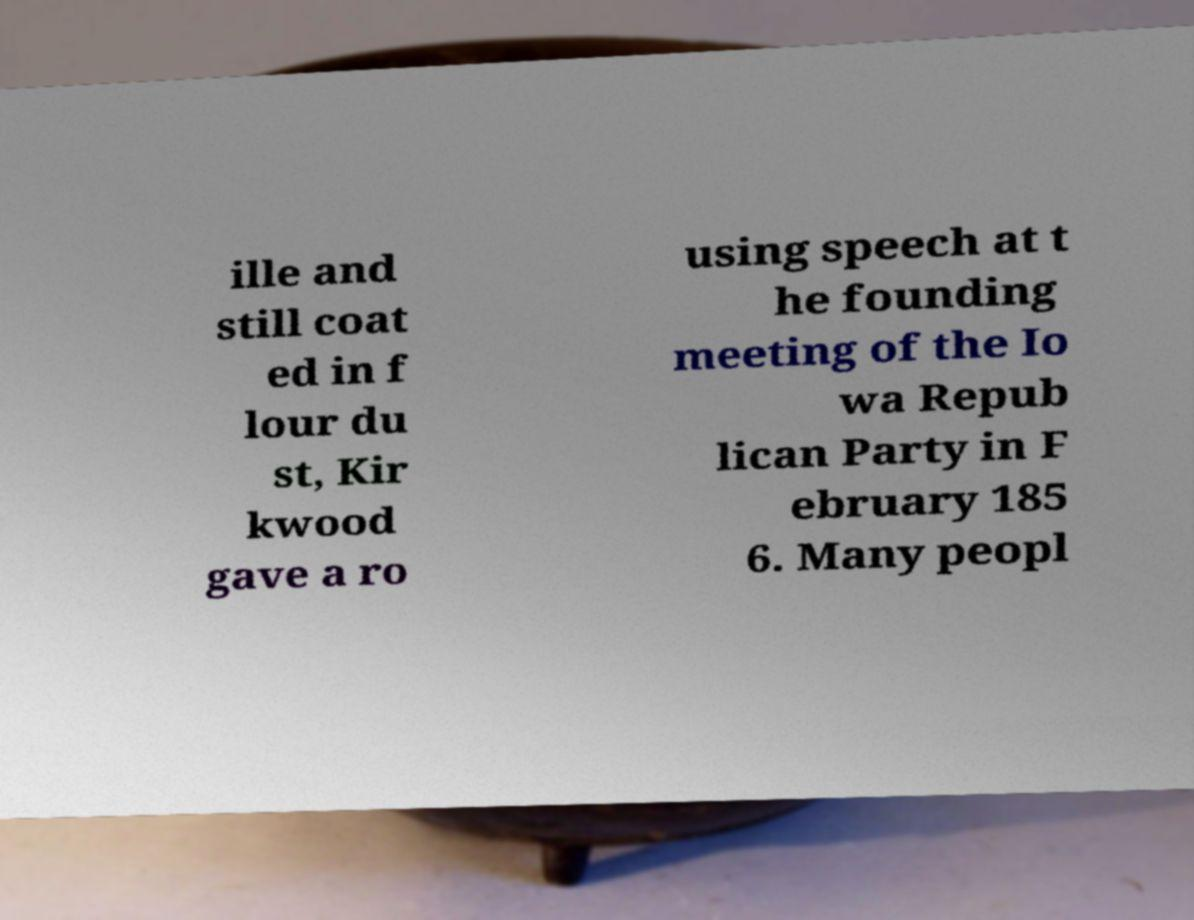Could you extract and type out the text from this image? ille and still coat ed in f lour du st, Kir kwood gave a ro using speech at t he founding meeting of the Io wa Repub lican Party in F ebruary 185 6. Many peopl 